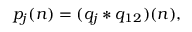Convert formula to latex. <formula><loc_0><loc_0><loc_500><loc_500>p _ { j } ( n ) = ( q _ { j } * q _ { 1 2 } ) ( n ) ,</formula> 